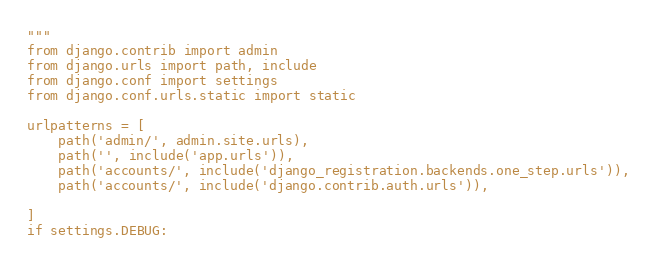Convert code to text. <code><loc_0><loc_0><loc_500><loc_500><_Python_>"""
from django.contrib import admin
from django.urls import path, include
from django.conf import settings
from django.conf.urls.static import static

urlpatterns = [
    path('admin/', admin.site.urls),
    path('', include('app.urls')),
    path('accounts/', include('django_registration.backends.one_step.urls')),
    path('accounts/', include('django.contrib.auth.urls')), 
    
]
if settings.DEBUG:</code> 